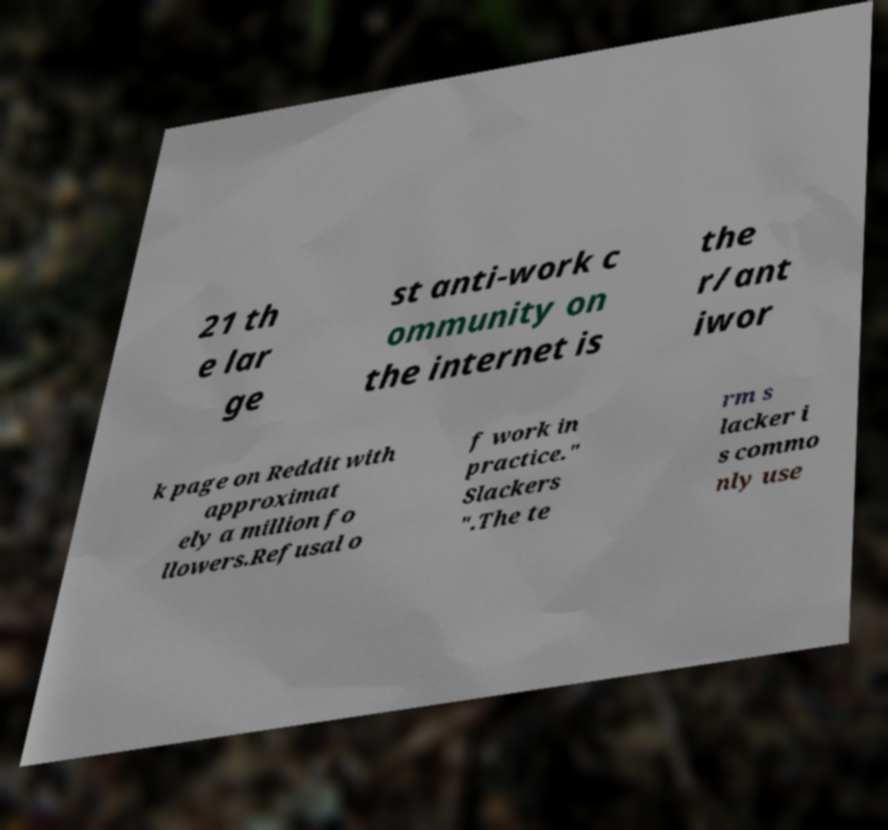There's text embedded in this image that I need extracted. Can you transcribe it verbatim? 21 th e lar ge st anti-work c ommunity on the internet is the r/ant iwor k page on Reddit with approximat ely a million fo llowers.Refusal o f work in practice." Slackers ".The te rm s lacker i s commo nly use 